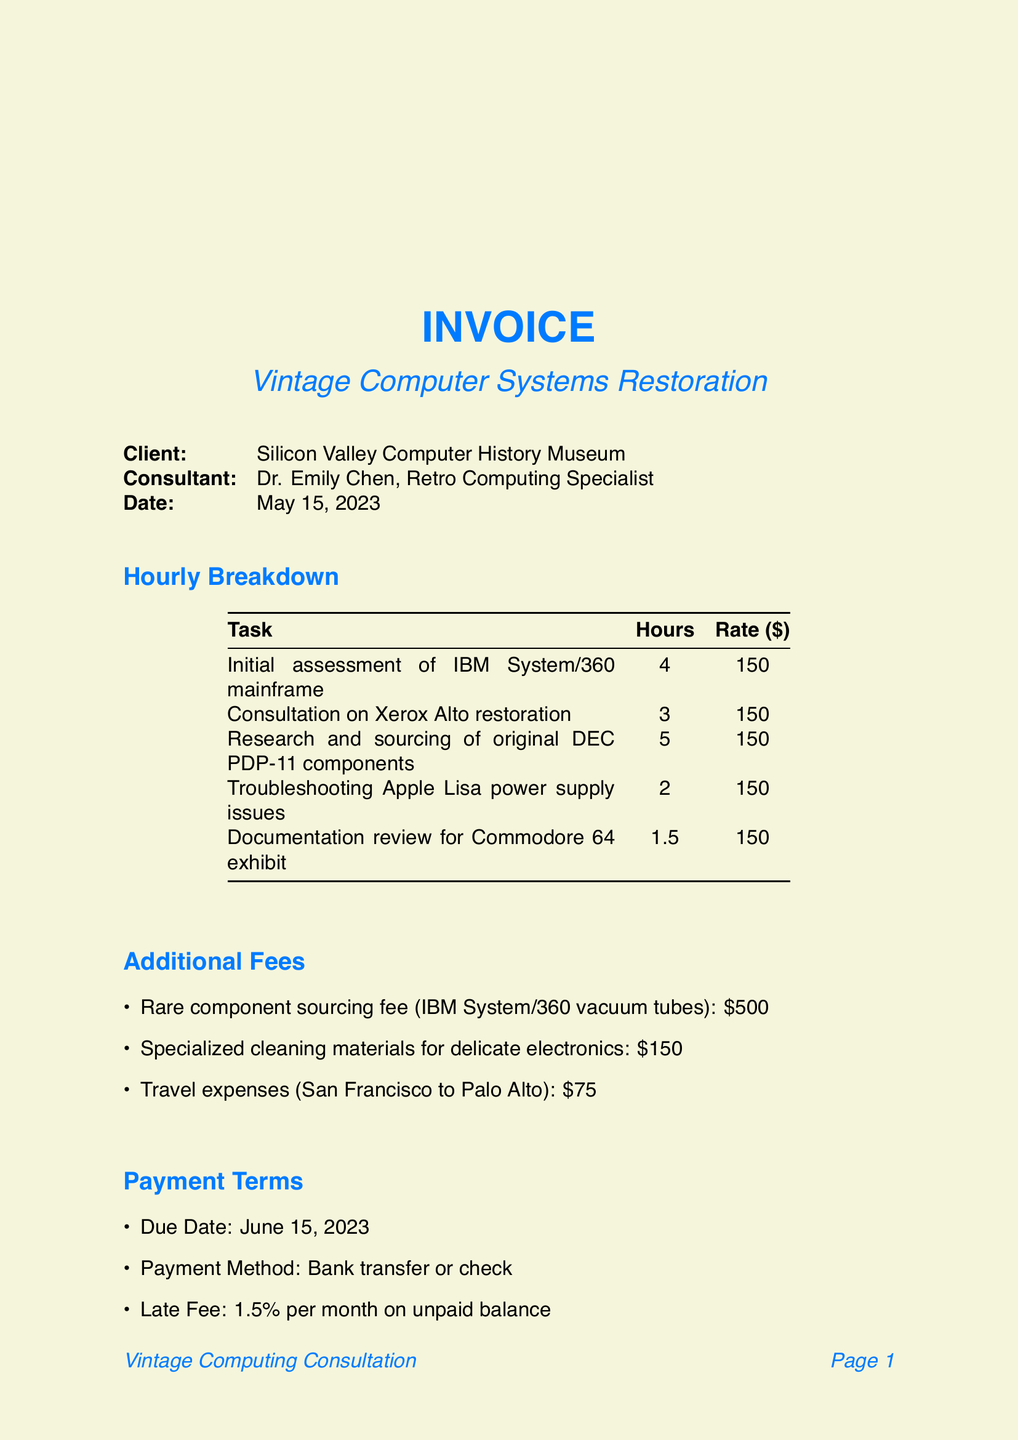What is the project name? The project name is clearly stated in the invoice details section.
Answer: Vintage Computer Systems Restoration Who is the consultant? The consultant's name and title are mentioned in the document.
Answer: Dr. Emily Chen, Retro Computing Specialist How many hours were billed for the initial assessment of the IBM System/360 mainframe? The hourly breakdown specifies the hours for each task.
Answer: 4 What is the total cost for the Rare component sourcing fee? The additional fees section lists the costs individually, including this specific fee.
Answer: 500 What is the due date for the payment? The payment terms section indicates the due date for the invoice.
Answer: June 15, 2023 How many hours were spent on troubleshooting the Apple Lisa power supply issues? The hourly breakdown provides specific hours for this task.
Answer: 2 What percentage is the late fee on an unpaid balance? The payment terms section states the late fee percentage.
Answer: 1.5% What is included in the follow-up services? One of the notes specifies what is included after consultations.
Answer: Follow-up email support for two weeks post-consultation What additional fees are associated with travel? The additional fees section contains this specific item's cost.
Answer: 75 